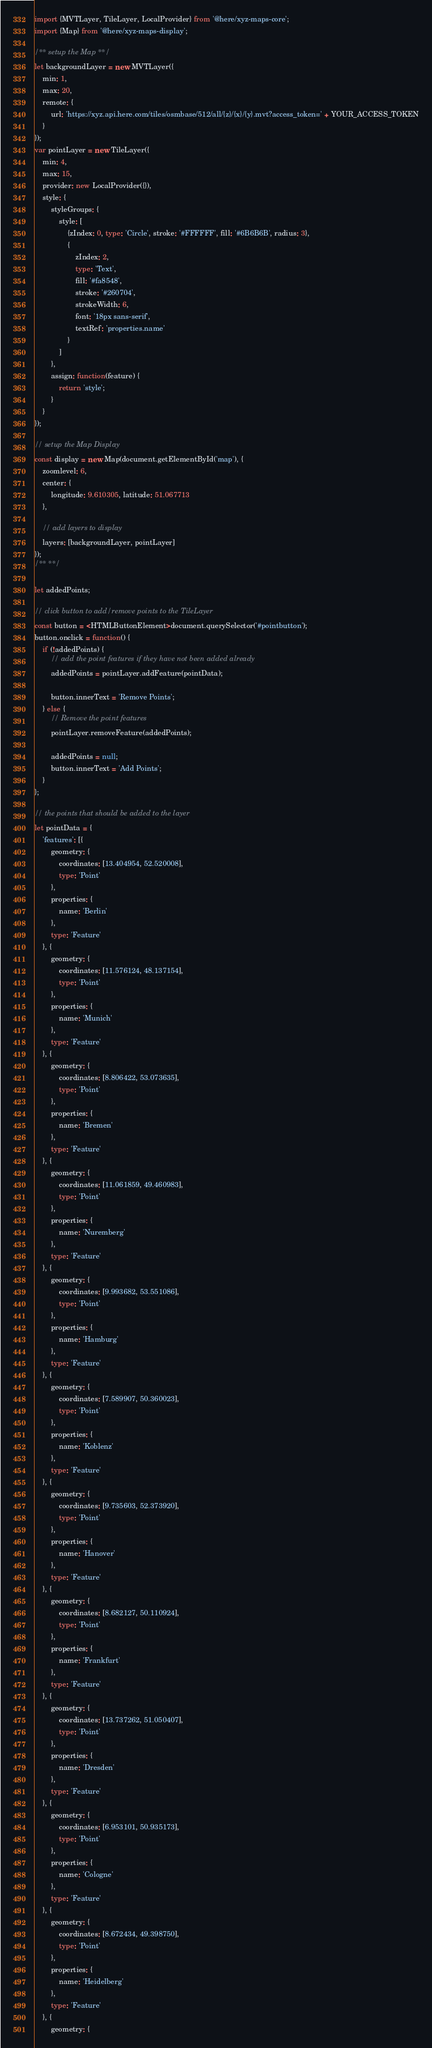Convert code to text. <code><loc_0><loc_0><loc_500><loc_500><_TypeScript_>import {MVTLayer, TileLayer, LocalProvider} from '@here/xyz-maps-core';
import {Map} from '@here/xyz-maps-display';

/** setup the Map **/
let backgroundLayer = new MVTLayer({
    min: 1,
    max: 20,
    remote: {
        url: 'https://xyz.api.here.com/tiles/osmbase/512/all/{z}/{x}/{y}.mvt?access_token=' + YOUR_ACCESS_TOKEN
    }
});
var pointLayer = new TileLayer({
    min: 4,
    max: 15,
    provider: new LocalProvider({}),
    style: {
        styleGroups: {
            style: [
                {zIndex: 0, type: 'Circle', stroke: '#FFFFFF', fill: '#6B6B6B', radius: 3},
                {
                    zIndex: 2,
                    type: 'Text',
                    fill: '#fa8548',
                    stroke: '#260704',
                    strokeWidth: 6,
                    font: '18px sans-serif',
                    textRef: 'properties.name'
                }
            ]
        },
        assign: function(feature) {
            return 'style';
        }
    }
});

// setup the Map Display
const display = new Map(document.getElementById('map'), {
    zoomlevel: 6,
    center: {
        longitude: 9.610305, latitude: 51.067713
    },

    // add layers to display
    layers: [backgroundLayer, pointLayer]
});
/** **/

let addedPoints;

// click button to add/remove points to the TileLayer
const button = <HTMLButtonElement>document.querySelector('#pointbutton');
button.onclick = function() {
    if (!addedPoints) {
        // add the point features if they have not been added already
        addedPoints = pointLayer.addFeature(pointData);

        button.innerText = 'Remove Points';
    } else {
        // Remove the point features
        pointLayer.removeFeature(addedPoints);

        addedPoints = null;
        button.innerText = 'Add Points';
    }
};

// the points that should be added to the layer
let pointData = {
    'features': [{
        geometry: {
            coordinates: [13.404954, 52.520008],
            type: 'Point'
        },
        properties: {
            name: 'Berlin'
        },
        type: 'Feature'
    }, {
        geometry: {
            coordinates: [11.576124, 48.137154],
            type: 'Point'
        },
        properties: {
            name: 'Munich'
        },
        type: 'Feature'
    }, {
        geometry: {
            coordinates: [8.806422, 53.073635],
            type: 'Point'
        },
        properties: {
            name: 'Bremen'
        },
        type: 'Feature'
    }, {
        geometry: {
            coordinates: [11.061859, 49.460983],
            type: 'Point'
        },
        properties: {
            name: 'Nuremberg'
        },
        type: 'Feature'
    }, {
        geometry: {
            coordinates: [9.993682, 53.551086],
            type: 'Point'
        },
        properties: {
            name: 'Hamburg'
        },
        type: 'Feature'
    }, {
        geometry: {
            coordinates: [7.589907, 50.360023],
            type: 'Point'
        },
        properties: {
            name: 'Koblenz'
        },
        type: 'Feature'
    }, {
        geometry: {
            coordinates: [9.735603, 52.373920],
            type: 'Point'
        },
        properties: {
            name: 'Hanover'
        },
        type: 'Feature'
    }, {
        geometry: {
            coordinates: [8.682127, 50.110924],
            type: 'Point'
        },
        properties: {
            name: 'Frankfurt'
        },
        type: 'Feature'
    }, {
        geometry: {
            coordinates: [13.737262, 51.050407],
            type: 'Point'
        },
        properties: {
            name: 'Dresden'
        },
        type: 'Feature'
    }, {
        geometry: {
            coordinates: [6.953101, 50.935173],
            type: 'Point'
        },
        properties: {
            name: 'Cologne'
        },
        type: 'Feature'
    }, {
        geometry: {
            coordinates: [8.672434, 49.398750],
            type: 'Point'
        },
        properties: {
            name: 'Heidelberg'
        },
        type: 'Feature'
    }, {
        geometry: {</code> 